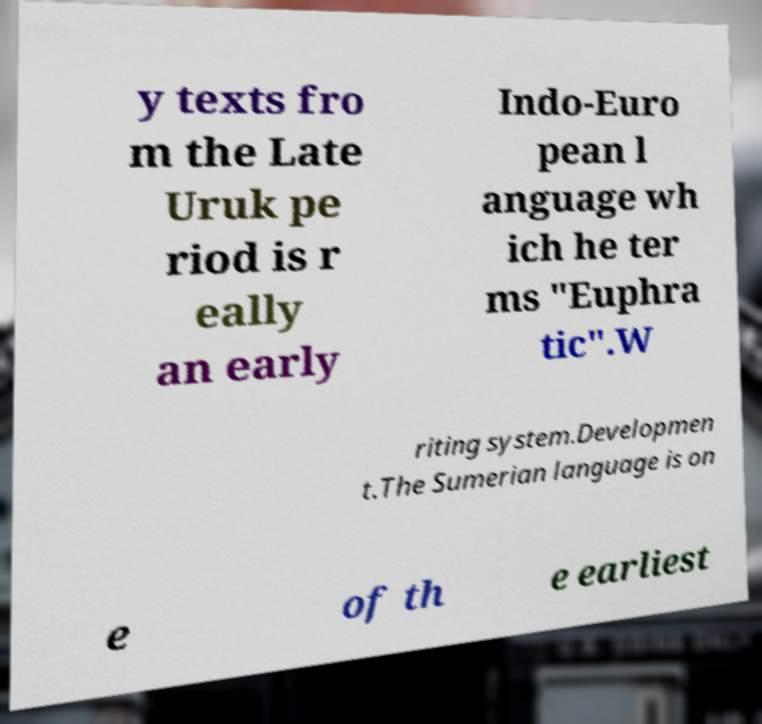Can you read and provide the text displayed in the image?This photo seems to have some interesting text. Can you extract and type it out for me? y texts fro m the Late Uruk pe riod is r eally an early Indo-Euro pean l anguage wh ich he ter ms "Euphra tic".W riting system.Developmen t.The Sumerian language is on e of th e earliest 